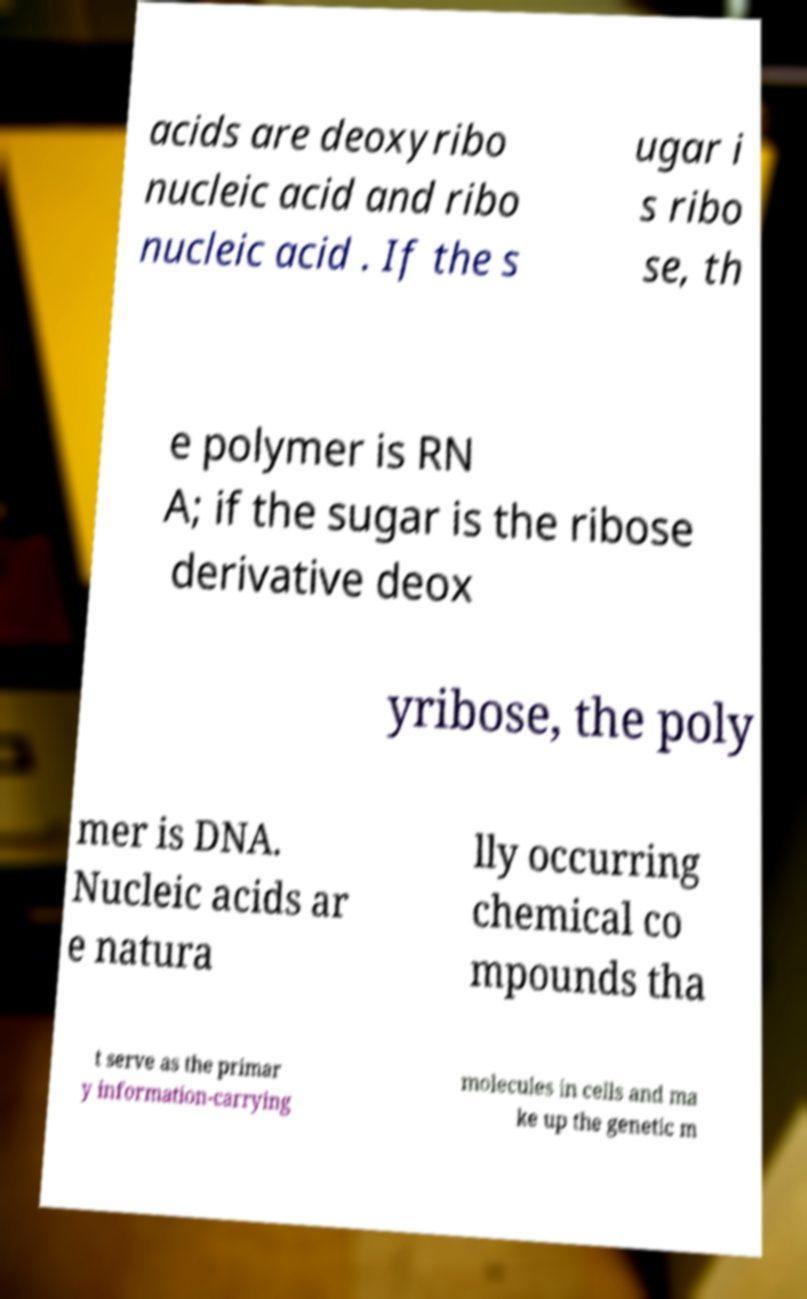Could you assist in decoding the text presented in this image and type it out clearly? acids are deoxyribo nucleic acid and ribo nucleic acid . If the s ugar i s ribo se, th e polymer is RN A; if the sugar is the ribose derivative deox yribose, the poly mer is DNA. Nucleic acids ar e natura lly occurring chemical co mpounds tha t serve as the primar y information-carrying molecules in cells and ma ke up the genetic m 